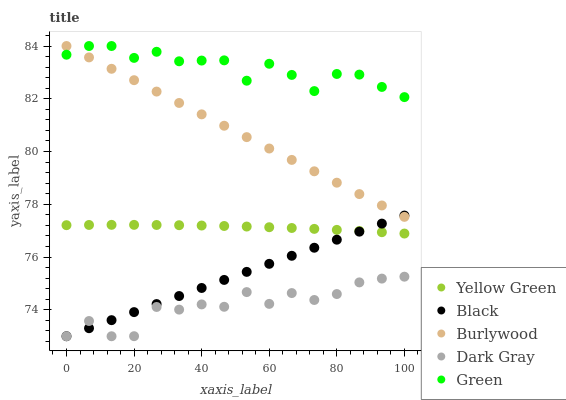Does Dark Gray have the minimum area under the curve?
Answer yes or no. Yes. Does Green have the maximum area under the curve?
Answer yes or no. Yes. Does Green have the minimum area under the curve?
Answer yes or no. No. Does Dark Gray have the maximum area under the curve?
Answer yes or no. No. Is Black the smoothest?
Answer yes or no. Yes. Is Dark Gray the roughest?
Answer yes or no. Yes. Is Green the smoothest?
Answer yes or no. No. Is Green the roughest?
Answer yes or no. No. Does Dark Gray have the lowest value?
Answer yes or no. Yes. Does Green have the lowest value?
Answer yes or no. No. Does Green have the highest value?
Answer yes or no. Yes. Does Dark Gray have the highest value?
Answer yes or no. No. Is Dark Gray less than Green?
Answer yes or no. Yes. Is Burlywood greater than Dark Gray?
Answer yes or no. Yes. Does Black intersect Dark Gray?
Answer yes or no. Yes. Is Black less than Dark Gray?
Answer yes or no. No. Is Black greater than Dark Gray?
Answer yes or no. No. Does Dark Gray intersect Green?
Answer yes or no. No. 